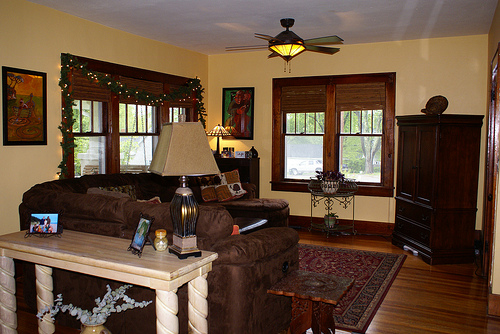What story could this room tell about its owners? This room reflects the tastes of individuals who value comfort, aesthetics, and family memories. The carefully arranged paintings and family portraits suggest a deep appreciation for art and heritage, while the cozy furnishings indicate a penchant for relaxation and warmth. The presence of plants and the floral arrangement highlight a love for nature and beauty, and the overall decor suggests a harmonious, inviting space curated with care and personal touch. Why might the owners have chosen these specific decorations and furniture? The owners likely chose these decorations and furniture to create a balanced blend of elegance and comfort. The detailed wooden table and ornate rugs convey a sense of sophistication and timeless style. Meanwhile, the pillows, cozy couch, and warm lighting all contribute to a space where comfort is paramount. The decorative elements like paintings and family photos add a personal touch, making the room uniquely theirs and filled with sentimental value. 